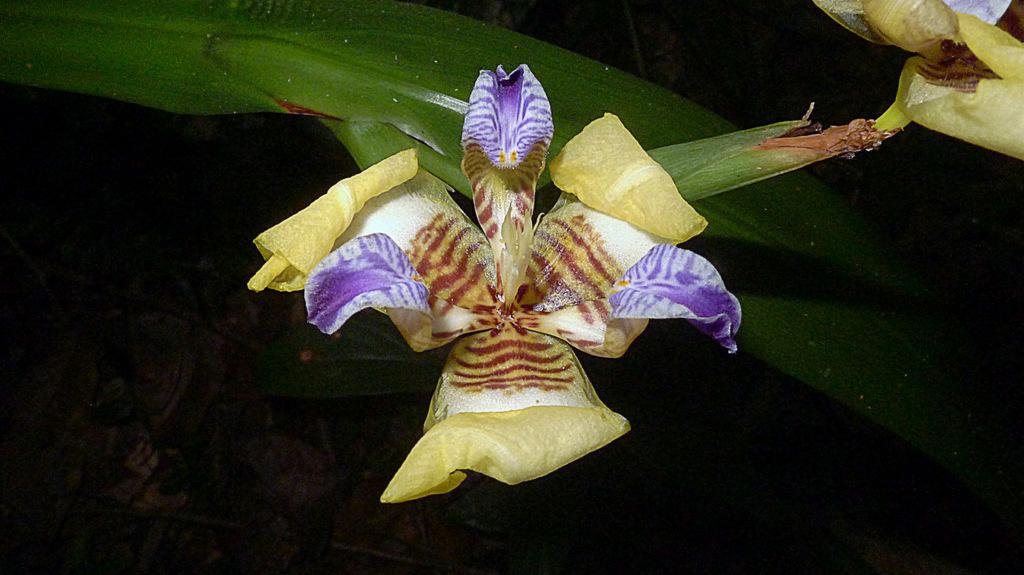What is present in the picture? There is a plant in the picture. What specific feature does the plant have? The plant has flowers. What else can be seen on the ground in the picture? There are dry leaves on the ground. What type of crown is the plant wearing in the image? There is no crown present in the image; it is a plant with flowers. What caused the dry leaves to fall on the ground in the image? The facts provided do not give any information about the cause of the dry leaves on the ground. 